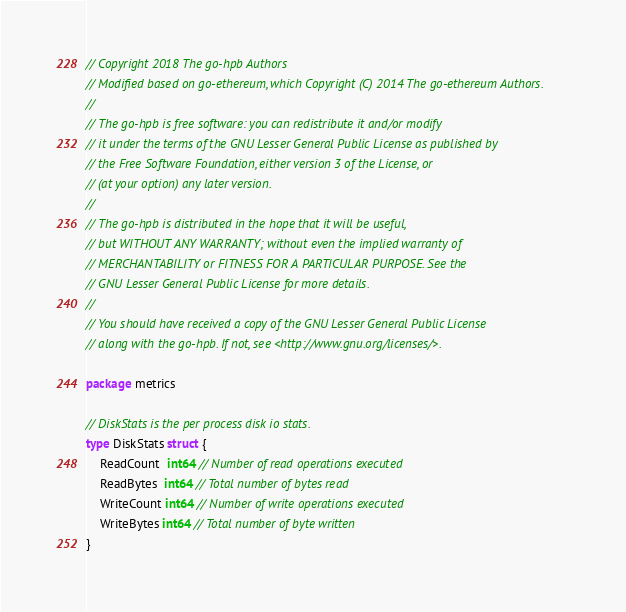<code> <loc_0><loc_0><loc_500><loc_500><_Go_>// Copyright 2018 The go-hpb Authors
// Modified based on go-ethereum, which Copyright (C) 2014 The go-ethereum Authors.
//
// The go-hpb is free software: you can redistribute it and/or modify
// it under the terms of the GNU Lesser General Public License as published by
// the Free Software Foundation, either version 3 of the License, or
// (at your option) any later version.
//
// The go-hpb is distributed in the hope that it will be useful,
// but WITHOUT ANY WARRANTY; without even the implied warranty of
// MERCHANTABILITY or FITNESS FOR A PARTICULAR PURPOSE. See the
// GNU Lesser General Public License for more details.
//
// You should have received a copy of the GNU Lesser General Public License
// along with the go-hpb. If not, see <http://www.gnu.org/licenses/>.

package metrics

// DiskStats is the per process disk io stats.
type DiskStats struct {
	ReadCount  int64 // Number of read operations executed
	ReadBytes  int64 // Total number of bytes read
	WriteCount int64 // Number of write operations executed
	WriteBytes int64 // Total number of byte written
}
</code> 